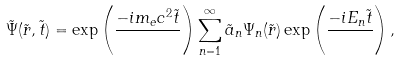<formula> <loc_0><loc_0><loc_500><loc_500>\tilde { \Psi } ( \tilde { r } , \tilde { t } ) = \exp \left ( \frac { - i m _ { e } c ^ { 2 } \tilde { t } } { } \right ) \sum ^ { \infty } _ { n = 1 } \tilde { a } _ { n } \Psi _ { n } ( \tilde { r } ) \exp \left ( \frac { - i E _ { n } \tilde { t } } { } \right ) ,</formula> 